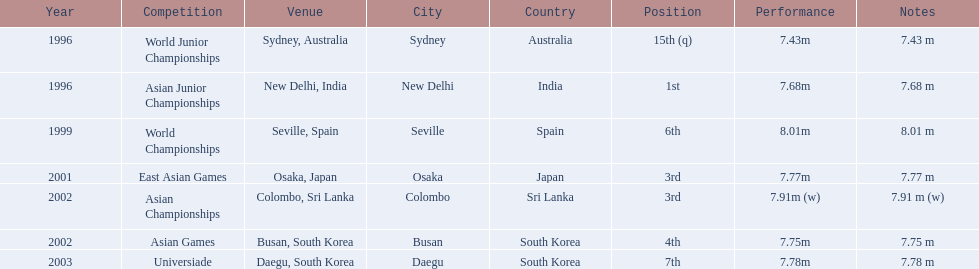Which competition did huang le achieve 3rd place? East Asian Games. Which competition did he achieve 4th place? Asian Games. When did he achieve 1st place? Asian Junior Championships. 